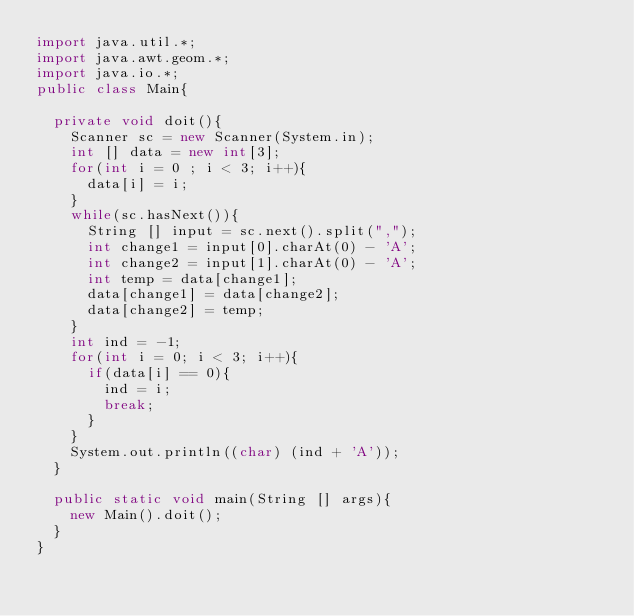<code> <loc_0><loc_0><loc_500><loc_500><_Java_>import java.util.*;
import java.awt.geom.*;
import java.io.*;
public class Main{
	
	private void doit(){
		Scanner sc = new Scanner(System.in);
		int [] data = new int[3];
		for(int i = 0 ; i < 3; i++){
			data[i] = i;
		}
		while(sc.hasNext()){
			String [] input = sc.next().split(",");
			int change1 = input[0].charAt(0) - 'A';
			int change2 = input[1].charAt(0) - 'A';
			int temp = data[change1];
			data[change1] = data[change2];
			data[change2] = temp;
		}
		int ind = -1;
		for(int i = 0; i < 3; i++){
			if(data[i] == 0){
				ind = i;
				break;
			}
		}
		System.out.println((char) (ind + 'A'));
	}

	public static void main(String [] args){
		new Main().doit();
	}
}</code> 